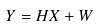Convert formula to latex. <formula><loc_0><loc_0><loc_500><loc_500>Y = H X + W</formula> 